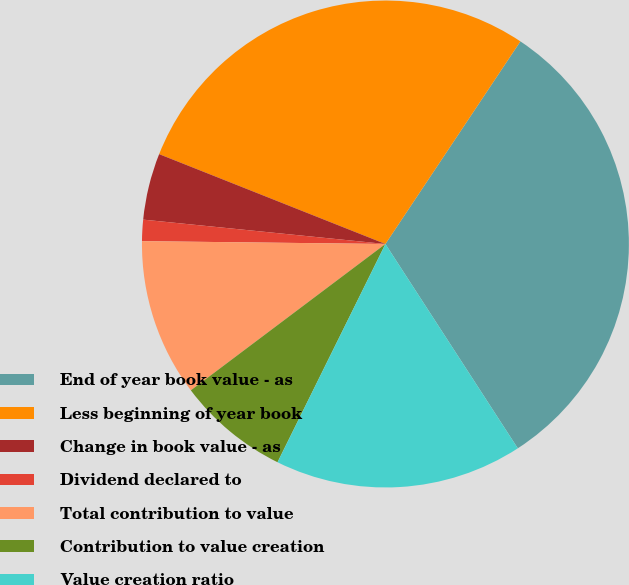<chart> <loc_0><loc_0><loc_500><loc_500><pie_chart><fcel>End of year book value - as<fcel>Less beginning of year book<fcel>Change in book value - as<fcel>Dividend declared to<fcel>Total contribution to value<fcel>Contribution to value creation<fcel>Value creation ratio<nl><fcel>31.5%<fcel>28.34%<fcel>4.42%<fcel>1.41%<fcel>10.45%<fcel>7.43%<fcel>16.46%<nl></chart> 